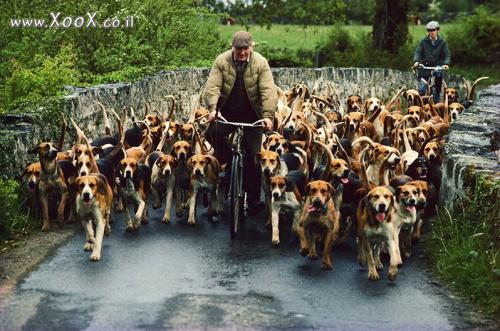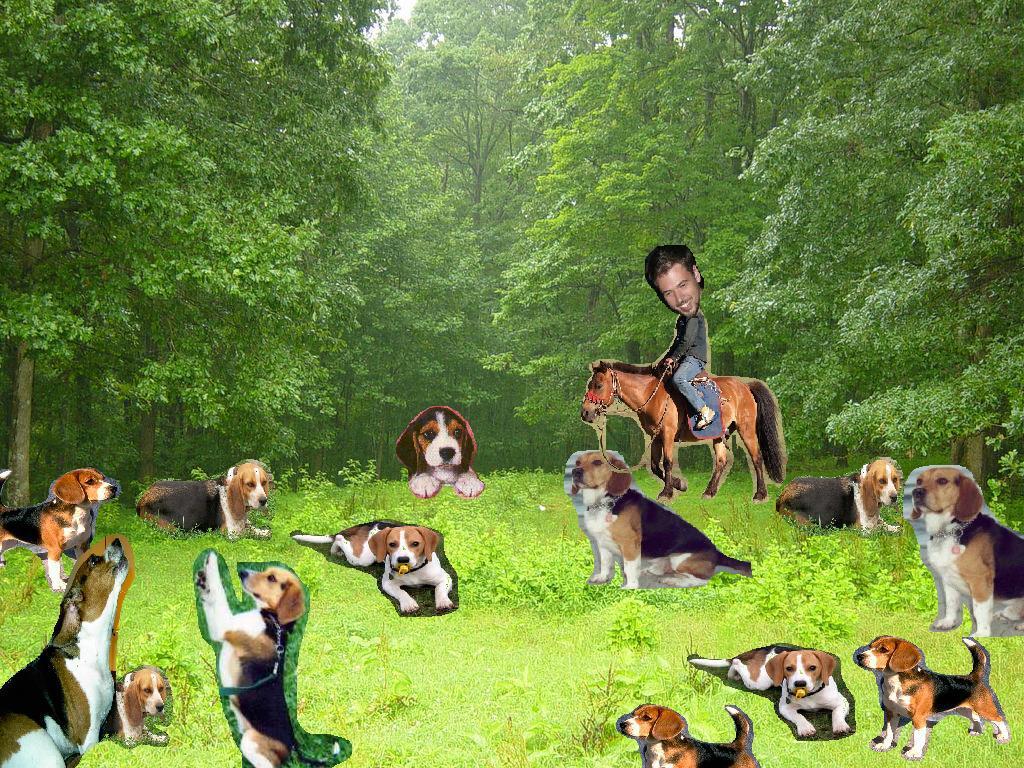The first image is the image on the left, the second image is the image on the right. Analyze the images presented: Is the assertion "A person is on the road with some of the dogs." valid? Answer yes or no. Yes. 